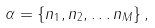<formula> <loc_0><loc_0><loc_500><loc_500>\alpha = \{ n _ { 1 } , n _ { 2 } , \dots n _ { M } \} \, ,</formula> 